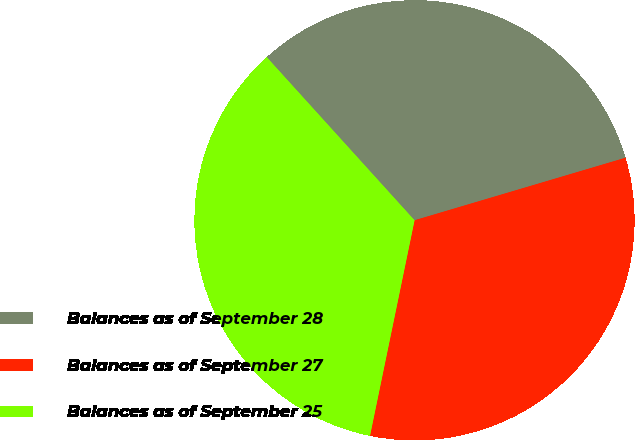Convert chart to OTSL. <chart><loc_0><loc_0><loc_500><loc_500><pie_chart><fcel>Balances as of September 28<fcel>Balances as of September 27<fcel>Balances as of September 25<nl><fcel>32.13%<fcel>32.83%<fcel>35.04%<nl></chart> 